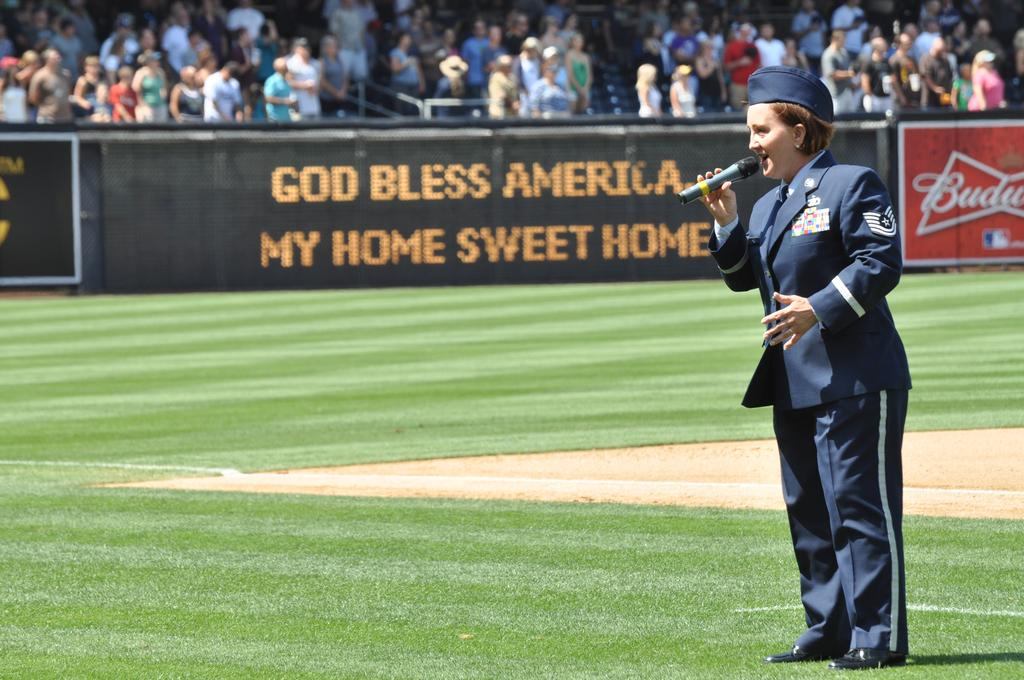<image>
Summarize the visual content of the image. female military member  with microphone as digital sign on wall has words going along god bless america my home sweet home 